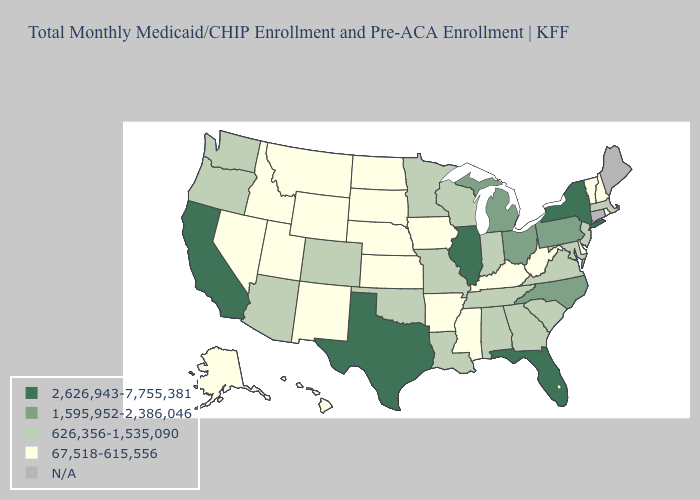Name the states that have a value in the range 1,595,952-2,386,046?
Answer briefly. Michigan, North Carolina, Ohio, Pennsylvania. Among the states that border Vermont , does New Hampshire have the lowest value?
Short answer required. Yes. Which states have the lowest value in the USA?
Write a very short answer. Alaska, Arkansas, Delaware, Hawaii, Idaho, Iowa, Kansas, Kentucky, Mississippi, Montana, Nebraska, Nevada, New Hampshire, New Mexico, North Dakota, Rhode Island, South Dakota, Utah, Vermont, West Virginia, Wyoming. What is the value of Alabama?
Short answer required. 626,356-1,535,090. Among the states that border Alabama , does Florida have the highest value?
Answer briefly. Yes. Does the map have missing data?
Give a very brief answer. Yes. What is the value of Utah?
Answer briefly. 67,518-615,556. What is the value of Pennsylvania?
Answer briefly. 1,595,952-2,386,046. Among the states that border Texas , does Louisiana have the lowest value?
Answer briefly. No. Which states hav the highest value in the MidWest?
Give a very brief answer. Illinois. What is the highest value in states that border Arizona?
Write a very short answer. 2,626,943-7,755,381. Which states have the highest value in the USA?
Be succinct. California, Florida, Illinois, New York, Texas. How many symbols are there in the legend?
Write a very short answer. 5. Name the states that have a value in the range 626,356-1,535,090?
Short answer required. Alabama, Arizona, Colorado, Georgia, Indiana, Louisiana, Maryland, Massachusetts, Minnesota, Missouri, New Jersey, Oklahoma, Oregon, South Carolina, Tennessee, Virginia, Washington, Wisconsin. Among the states that border California , which have the highest value?
Quick response, please. Arizona, Oregon. 